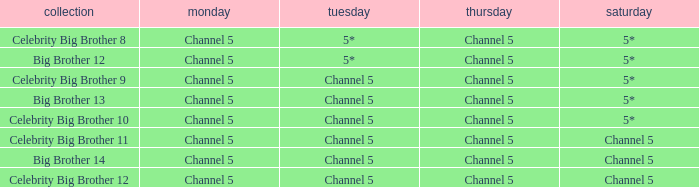Which series airs Saturday on Channel 5? Celebrity Big Brother 11, Big Brother 14, Celebrity Big Brother 12. 